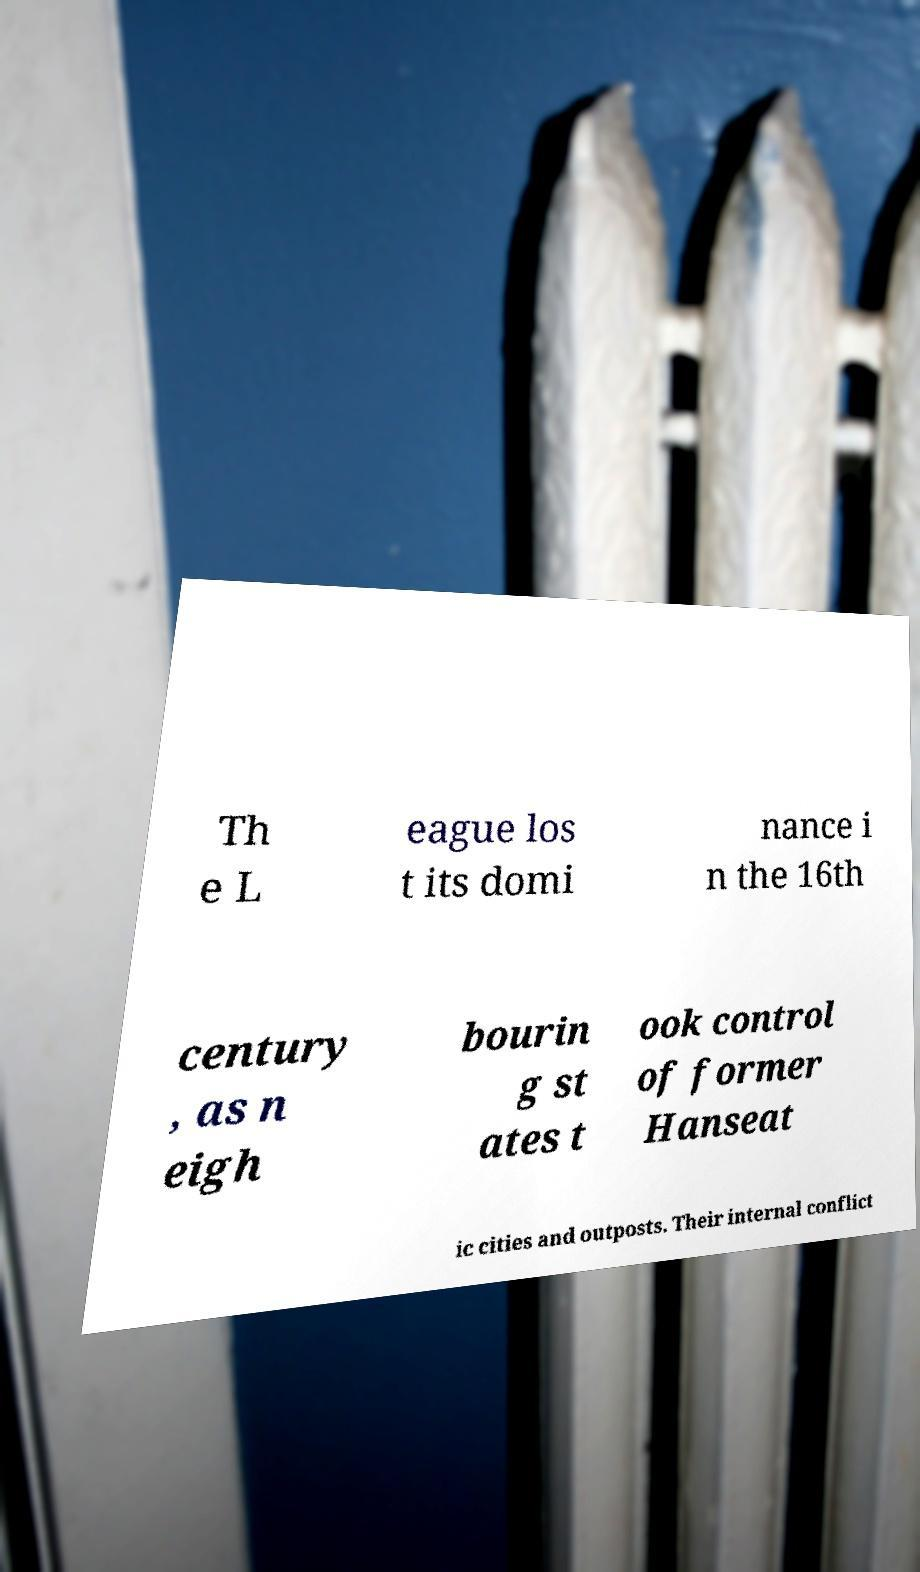There's text embedded in this image that I need extracted. Can you transcribe it verbatim? Th e L eague los t its domi nance i n the 16th century , as n eigh bourin g st ates t ook control of former Hanseat ic cities and outposts. Their internal conflict 